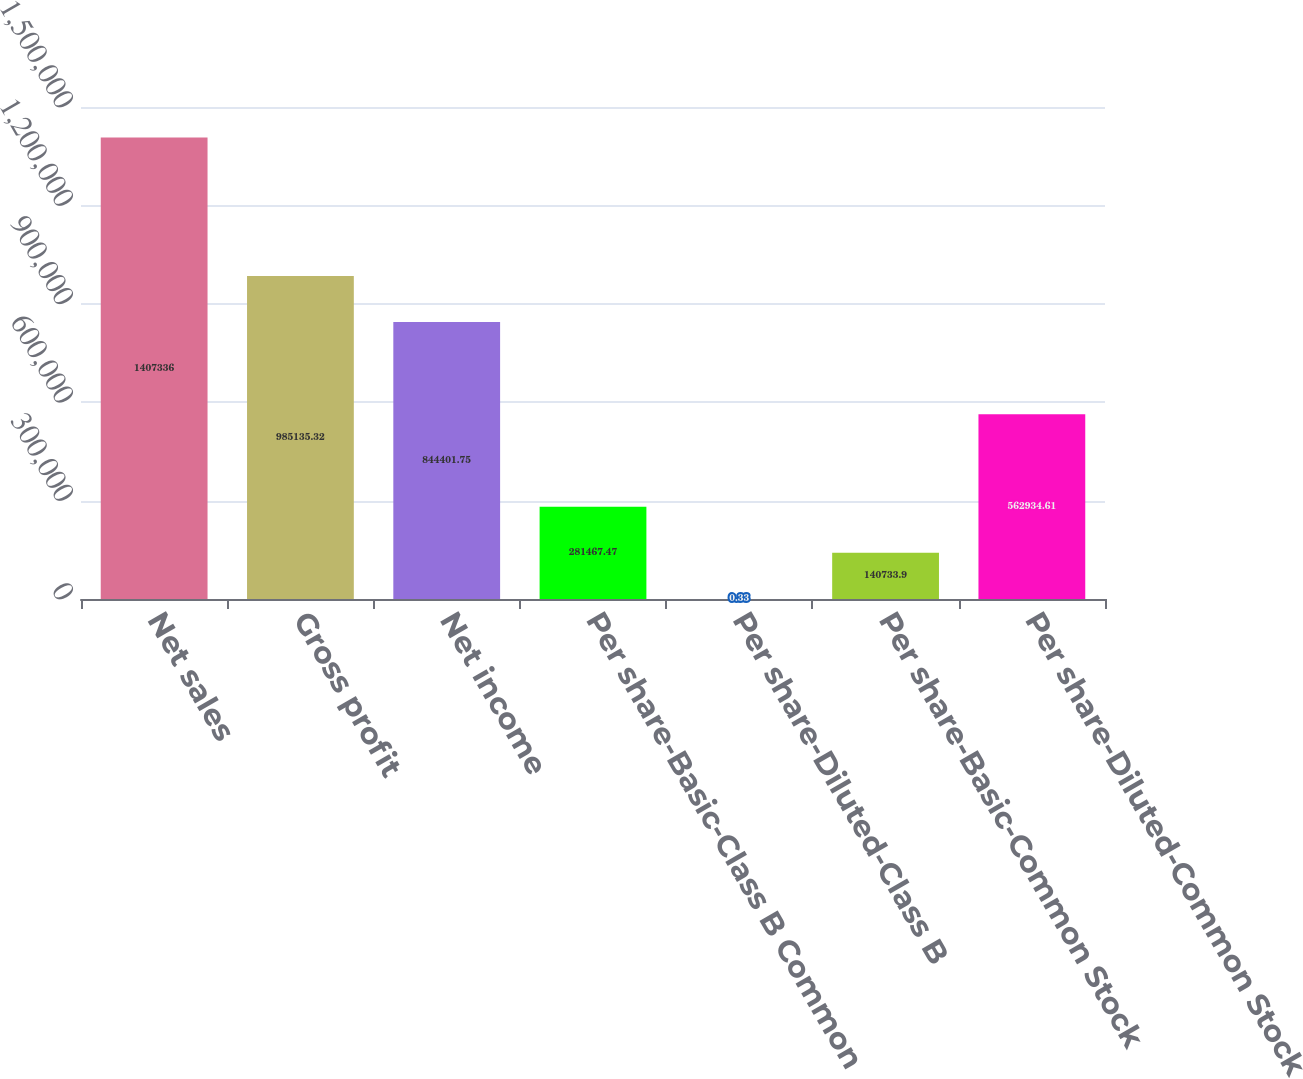Convert chart. <chart><loc_0><loc_0><loc_500><loc_500><bar_chart><fcel>Net sales<fcel>Gross profit<fcel>Net income<fcel>Per share-Basic-Class B Common<fcel>Per share-Diluted-Class B<fcel>Per share-Basic-Common Stock<fcel>Per share-Diluted-Common Stock<nl><fcel>1.40734e+06<fcel>985135<fcel>844402<fcel>281467<fcel>0.33<fcel>140734<fcel>562935<nl></chart> 